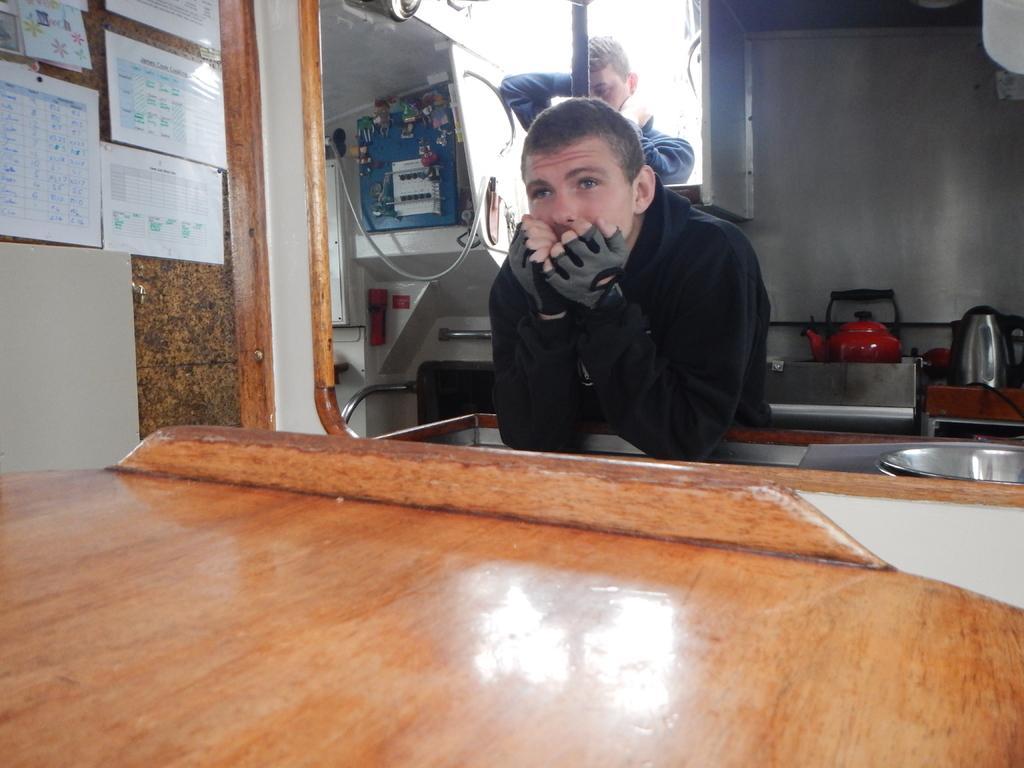Can you describe this image briefly? In the foreground of the picture I can see the wooden table. There is a man wearing a black color coat and I can see the gloves on his hands. In the background, I can see another man. I can see the white sheet papers on the wall on the top left side of the picture. I can see a red color tea jar and a flask on the right side. It is looking like an electric board. 